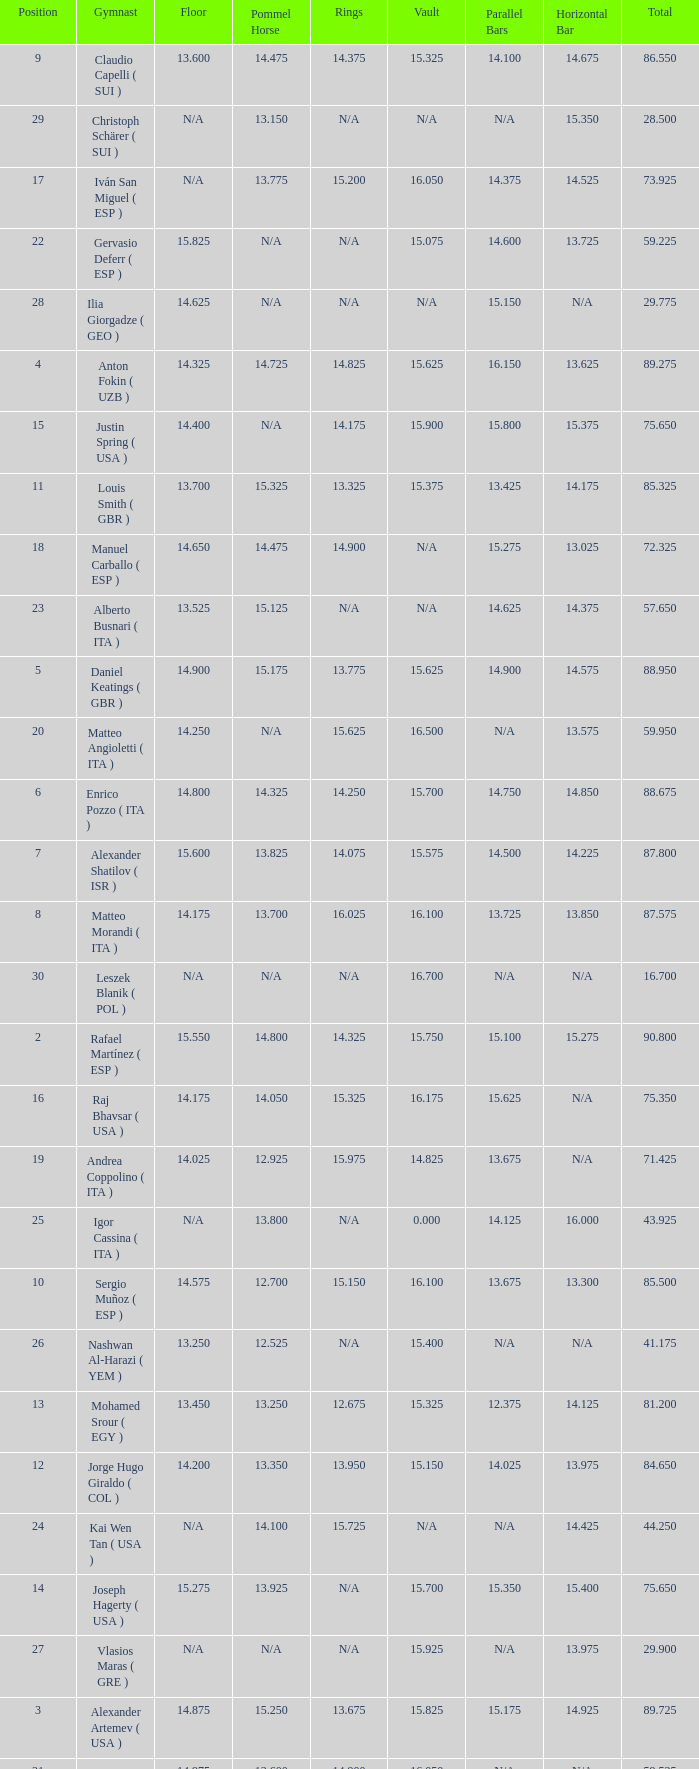If the parallel bars is 16.150, who is the gymnast? Anton Fokin ( UZB ). 